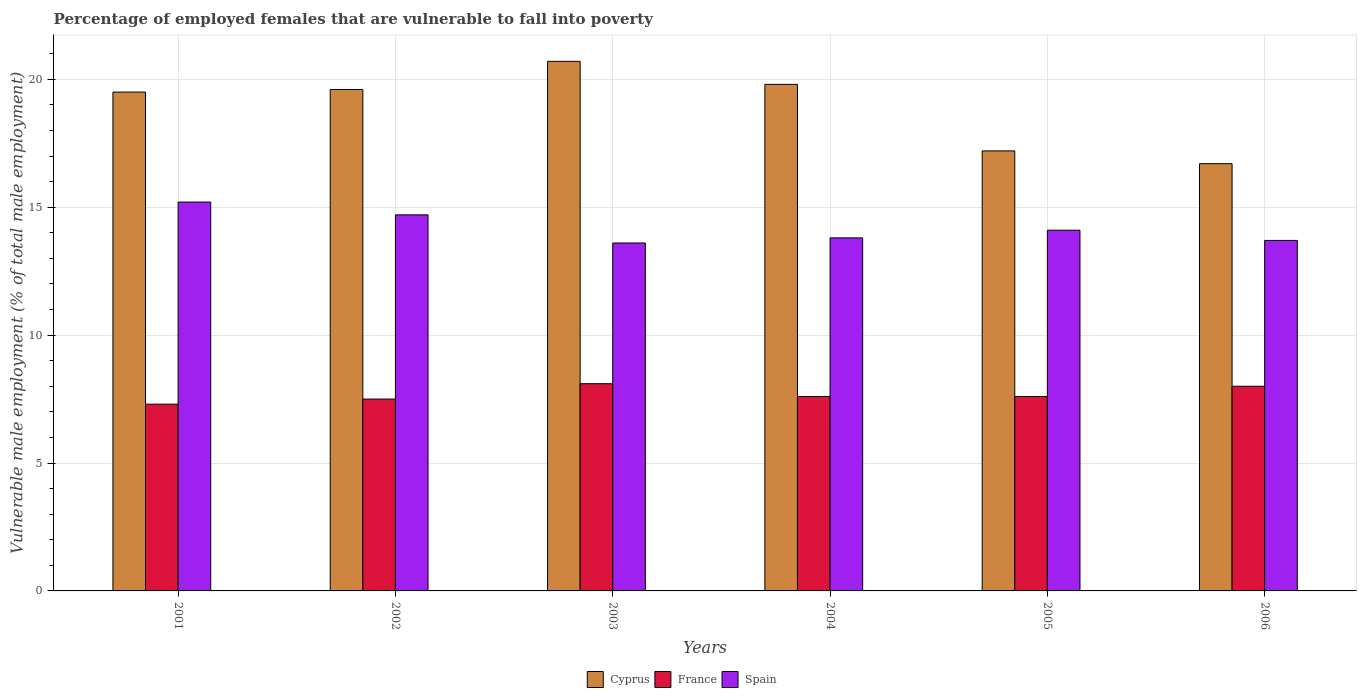Are the number of bars on each tick of the X-axis equal?
Provide a short and direct response. Yes. How many bars are there on the 4th tick from the left?
Your response must be concise. 3. In how many cases, is the number of bars for a given year not equal to the number of legend labels?
Your answer should be compact. 0. What is the percentage of employed females who are vulnerable to fall into poverty in France in 2005?
Offer a terse response. 7.6. Across all years, what is the maximum percentage of employed females who are vulnerable to fall into poverty in France?
Your answer should be very brief. 8.1. Across all years, what is the minimum percentage of employed females who are vulnerable to fall into poverty in France?
Make the answer very short. 7.3. What is the total percentage of employed females who are vulnerable to fall into poverty in Spain in the graph?
Your answer should be compact. 85.1. What is the difference between the percentage of employed females who are vulnerable to fall into poverty in France in 2001 and that in 2004?
Provide a succinct answer. -0.3. What is the difference between the percentage of employed females who are vulnerable to fall into poverty in France in 2001 and the percentage of employed females who are vulnerable to fall into poverty in Spain in 2004?
Offer a terse response. -6.5. What is the average percentage of employed females who are vulnerable to fall into poverty in Cyprus per year?
Keep it short and to the point. 18.92. In the year 2001, what is the difference between the percentage of employed females who are vulnerable to fall into poverty in France and percentage of employed females who are vulnerable to fall into poverty in Spain?
Give a very brief answer. -7.9. What is the ratio of the percentage of employed females who are vulnerable to fall into poverty in France in 2002 to that in 2004?
Provide a succinct answer. 0.99. Is the difference between the percentage of employed females who are vulnerable to fall into poverty in France in 2002 and 2004 greater than the difference between the percentage of employed females who are vulnerable to fall into poverty in Spain in 2002 and 2004?
Make the answer very short. No. What is the difference between the highest and the lowest percentage of employed females who are vulnerable to fall into poverty in Spain?
Make the answer very short. 1.6. In how many years, is the percentage of employed females who are vulnerable to fall into poverty in Cyprus greater than the average percentage of employed females who are vulnerable to fall into poverty in Cyprus taken over all years?
Your answer should be compact. 4. How many bars are there?
Provide a succinct answer. 18. How many years are there in the graph?
Provide a succinct answer. 6. What is the difference between two consecutive major ticks on the Y-axis?
Make the answer very short. 5. Are the values on the major ticks of Y-axis written in scientific E-notation?
Offer a very short reply. No. Does the graph contain grids?
Make the answer very short. Yes. Where does the legend appear in the graph?
Keep it short and to the point. Bottom center. How are the legend labels stacked?
Your answer should be compact. Horizontal. What is the title of the graph?
Provide a short and direct response. Percentage of employed females that are vulnerable to fall into poverty. What is the label or title of the X-axis?
Your answer should be compact. Years. What is the label or title of the Y-axis?
Your answer should be very brief. Vulnerable male employment (% of total male employment). What is the Vulnerable male employment (% of total male employment) in Cyprus in 2001?
Your response must be concise. 19.5. What is the Vulnerable male employment (% of total male employment) of France in 2001?
Your answer should be compact. 7.3. What is the Vulnerable male employment (% of total male employment) in Spain in 2001?
Ensure brevity in your answer.  15.2. What is the Vulnerable male employment (% of total male employment) in Cyprus in 2002?
Offer a terse response. 19.6. What is the Vulnerable male employment (% of total male employment) in Spain in 2002?
Keep it short and to the point. 14.7. What is the Vulnerable male employment (% of total male employment) in Cyprus in 2003?
Your answer should be very brief. 20.7. What is the Vulnerable male employment (% of total male employment) of France in 2003?
Your response must be concise. 8.1. What is the Vulnerable male employment (% of total male employment) in Spain in 2003?
Provide a succinct answer. 13.6. What is the Vulnerable male employment (% of total male employment) of Cyprus in 2004?
Provide a succinct answer. 19.8. What is the Vulnerable male employment (% of total male employment) of France in 2004?
Give a very brief answer. 7.6. What is the Vulnerable male employment (% of total male employment) of Spain in 2004?
Ensure brevity in your answer.  13.8. What is the Vulnerable male employment (% of total male employment) in Cyprus in 2005?
Offer a very short reply. 17.2. What is the Vulnerable male employment (% of total male employment) in France in 2005?
Your answer should be compact. 7.6. What is the Vulnerable male employment (% of total male employment) in Spain in 2005?
Your answer should be compact. 14.1. What is the Vulnerable male employment (% of total male employment) of Cyprus in 2006?
Provide a short and direct response. 16.7. What is the Vulnerable male employment (% of total male employment) in France in 2006?
Keep it short and to the point. 8. What is the Vulnerable male employment (% of total male employment) in Spain in 2006?
Offer a terse response. 13.7. Across all years, what is the maximum Vulnerable male employment (% of total male employment) in Cyprus?
Your answer should be compact. 20.7. Across all years, what is the maximum Vulnerable male employment (% of total male employment) in France?
Ensure brevity in your answer.  8.1. Across all years, what is the maximum Vulnerable male employment (% of total male employment) in Spain?
Provide a short and direct response. 15.2. Across all years, what is the minimum Vulnerable male employment (% of total male employment) in Cyprus?
Keep it short and to the point. 16.7. Across all years, what is the minimum Vulnerable male employment (% of total male employment) in France?
Provide a succinct answer. 7.3. Across all years, what is the minimum Vulnerable male employment (% of total male employment) of Spain?
Make the answer very short. 13.6. What is the total Vulnerable male employment (% of total male employment) of Cyprus in the graph?
Give a very brief answer. 113.5. What is the total Vulnerable male employment (% of total male employment) of France in the graph?
Your response must be concise. 46.1. What is the total Vulnerable male employment (% of total male employment) in Spain in the graph?
Offer a terse response. 85.1. What is the difference between the Vulnerable male employment (% of total male employment) of France in 2001 and that in 2003?
Provide a short and direct response. -0.8. What is the difference between the Vulnerable male employment (% of total male employment) of Spain in 2001 and that in 2003?
Give a very brief answer. 1.6. What is the difference between the Vulnerable male employment (% of total male employment) in France in 2001 and that in 2004?
Ensure brevity in your answer.  -0.3. What is the difference between the Vulnerable male employment (% of total male employment) of Spain in 2001 and that in 2005?
Make the answer very short. 1.1. What is the difference between the Vulnerable male employment (% of total male employment) of France in 2001 and that in 2006?
Your answer should be compact. -0.7. What is the difference between the Vulnerable male employment (% of total male employment) in Cyprus in 2002 and that in 2004?
Give a very brief answer. -0.2. What is the difference between the Vulnerable male employment (% of total male employment) of Cyprus in 2002 and that in 2005?
Your answer should be very brief. 2.4. What is the difference between the Vulnerable male employment (% of total male employment) in France in 2002 and that in 2005?
Provide a short and direct response. -0.1. What is the difference between the Vulnerable male employment (% of total male employment) in Cyprus in 2002 and that in 2006?
Offer a terse response. 2.9. What is the difference between the Vulnerable male employment (% of total male employment) in France in 2002 and that in 2006?
Your answer should be compact. -0.5. What is the difference between the Vulnerable male employment (% of total male employment) in Cyprus in 2003 and that in 2005?
Make the answer very short. 3.5. What is the difference between the Vulnerable male employment (% of total male employment) of France in 2003 and that in 2005?
Give a very brief answer. 0.5. What is the difference between the Vulnerable male employment (% of total male employment) of Spain in 2003 and that in 2005?
Keep it short and to the point. -0.5. What is the difference between the Vulnerable male employment (% of total male employment) of Cyprus in 2003 and that in 2006?
Your answer should be compact. 4. What is the difference between the Vulnerable male employment (% of total male employment) of France in 2003 and that in 2006?
Your answer should be compact. 0.1. What is the difference between the Vulnerable male employment (% of total male employment) of France in 2004 and that in 2005?
Offer a very short reply. 0. What is the difference between the Vulnerable male employment (% of total male employment) in Spain in 2004 and that in 2005?
Ensure brevity in your answer.  -0.3. What is the difference between the Vulnerable male employment (% of total male employment) in Cyprus in 2004 and that in 2006?
Provide a succinct answer. 3.1. What is the difference between the Vulnerable male employment (% of total male employment) of Cyprus in 2005 and that in 2006?
Keep it short and to the point. 0.5. What is the difference between the Vulnerable male employment (% of total male employment) in France in 2005 and that in 2006?
Offer a very short reply. -0.4. What is the difference between the Vulnerable male employment (% of total male employment) in Cyprus in 2001 and the Vulnerable male employment (% of total male employment) in Spain in 2002?
Ensure brevity in your answer.  4.8. What is the difference between the Vulnerable male employment (% of total male employment) in Cyprus in 2001 and the Vulnerable male employment (% of total male employment) in France in 2003?
Your answer should be compact. 11.4. What is the difference between the Vulnerable male employment (% of total male employment) in Cyprus in 2001 and the Vulnerable male employment (% of total male employment) in Spain in 2003?
Provide a succinct answer. 5.9. What is the difference between the Vulnerable male employment (% of total male employment) of France in 2001 and the Vulnerable male employment (% of total male employment) of Spain in 2003?
Provide a succinct answer. -6.3. What is the difference between the Vulnerable male employment (% of total male employment) in Cyprus in 2001 and the Vulnerable male employment (% of total male employment) in France in 2004?
Your response must be concise. 11.9. What is the difference between the Vulnerable male employment (% of total male employment) in Cyprus in 2001 and the Vulnerable male employment (% of total male employment) in Spain in 2004?
Offer a very short reply. 5.7. What is the difference between the Vulnerable male employment (% of total male employment) in France in 2001 and the Vulnerable male employment (% of total male employment) in Spain in 2004?
Provide a short and direct response. -6.5. What is the difference between the Vulnerable male employment (% of total male employment) in Cyprus in 2001 and the Vulnerable male employment (% of total male employment) in France in 2005?
Ensure brevity in your answer.  11.9. What is the difference between the Vulnerable male employment (% of total male employment) of France in 2001 and the Vulnerable male employment (% of total male employment) of Spain in 2005?
Offer a terse response. -6.8. What is the difference between the Vulnerable male employment (% of total male employment) of France in 2001 and the Vulnerable male employment (% of total male employment) of Spain in 2006?
Offer a terse response. -6.4. What is the difference between the Vulnerable male employment (% of total male employment) of Cyprus in 2002 and the Vulnerable male employment (% of total male employment) of Spain in 2003?
Your answer should be compact. 6. What is the difference between the Vulnerable male employment (% of total male employment) of France in 2002 and the Vulnerable male employment (% of total male employment) of Spain in 2003?
Offer a terse response. -6.1. What is the difference between the Vulnerable male employment (% of total male employment) in Cyprus in 2002 and the Vulnerable male employment (% of total male employment) in France in 2004?
Make the answer very short. 12. What is the difference between the Vulnerable male employment (% of total male employment) in Cyprus in 2002 and the Vulnerable male employment (% of total male employment) in Spain in 2004?
Offer a terse response. 5.8. What is the difference between the Vulnerable male employment (% of total male employment) in Cyprus in 2002 and the Vulnerable male employment (% of total male employment) in Spain in 2005?
Offer a very short reply. 5.5. What is the difference between the Vulnerable male employment (% of total male employment) in Cyprus in 2002 and the Vulnerable male employment (% of total male employment) in France in 2006?
Keep it short and to the point. 11.6. What is the difference between the Vulnerable male employment (% of total male employment) of Cyprus in 2003 and the Vulnerable male employment (% of total male employment) of Spain in 2005?
Give a very brief answer. 6.6. What is the difference between the Vulnerable male employment (% of total male employment) of France in 2004 and the Vulnerable male employment (% of total male employment) of Spain in 2005?
Make the answer very short. -6.5. What is the difference between the Vulnerable male employment (% of total male employment) in Cyprus in 2004 and the Vulnerable male employment (% of total male employment) in France in 2006?
Provide a succinct answer. 11.8. What is the difference between the Vulnerable male employment (% of total male employment) in France in 2004 and the Vulnerable male employment (% of total male employment) in Spain in 2006?
Your answer should be compact. -6.1. What is the difference between the Vulnerable male employment (% of total male employment) of Cyprus in 2005 and the Vulnerable male employment (% of total male employment) of France in 2006?
Offer a terse response. 9.2. What is the difference between the Vulnerable male employment (% of total male employment) of France in 2005 and the Vulnerable male employment (% of total male employment) of Spain in 2006?
Keep it short and to the point. -6.1. What is the average Vulnerable male employment (% of total male employment) in Cyprus per year?
Keep it short and to the point. 18.92. What is the average Vulnerable male employment (% of total male employment) of France per year?
Keep it short and to the point. 7.68. What is the average Vulnerable male employment (% of total male employment) of Spain per year?
Offer a terse response. 14.18. In the year 2001, what is the difference between the Vulnerable male employment (% of total male employment) of Cyprus and Vulnerable male employment (% of total male employment) of Spain?
Provide a succinct answer. 4.3. In the year 2001, what is the difference between the Vulnerable male employment (% of total male employment) in France and Vulnerable male employment (% of total male employment) in Spain?
Provide a succinct answer. -7.9. In the year 2003, what is the difference between the Vulnerable male employment (% of total male employment) of Cyprus and Vulnerable male employment (% of total male employment) of Spain?
Make the answer very short. 7.1. In the year 2003, what is the difference between the Vulnerable male employment (% of total male employment) in France and Vulnerable male employment (% of total male employment) in Spain?
Offer a very short reply. -5.5. In the year 2004, what is the difference between the Vulnerable male employment (% of total male employment) of France and Vulnerable male employment (% of total male employment) of Spain?
Keep it short and to the point. -6.2. In the year 2005, what is the difference between the Vulnerable male employment (% of total male employment) of Cyprus and Vulnerable male employment (% of total male employment) of France?
Give a very brief answer. 9.6. In the year 2005, what is the difference between the Vulnerable male employment (% of total male employment) of Cyprus and Vulnerable male employment (% of total male employment) of Spain?
Make the answer very short. 3.1. In the year 2005, what is the difference between the Vulnerable male employment (% of total male employment) in France and Vulnerable male employment (% of total male employment) in Spain?
Ensure brevity in your answer.  -6.5. In the year 2006, what is the difference between the Vulnerable male employment (% of total male employment) in France and Vulnerable male employment (% of total male employment) in Spain?
Keep it short and to the point. -5.7. What is the ratio of the Vulnerable male employment (% of total male employment) of Cyprus in 2001 to that in 2002?
Your response must be concise. 0.99. What is the ratio of the Vulnerable male employment (% of total male employment) in France in 2001 to that in 2002?
Offer a terse response. 0.97. What is the ratio of the Vulnerable male employment (% of total male employment) in Spain in 2001 to that in 2002?
Give a very brief answer. 1.03. What is the ratio of the Vulnerable male employment (% of total male employment) in Cyprus in 2001 to that in 2003?
Provide a short and direct response. 0.94. What is the ratio of the Vulnerable male employment (% of total male employment) in France in 2001 to that in 2003?
Make the answer very short. 0.9. What is the ratio of the Vulnerable male employment (% of total male employment) in Spain in 2001 to that in 2003?
Offer a very short reply. 1.12. What is the ratio of the Vulnerable male employment (% of total male employment) in France in 2001 to that in 2004?
Ensure brevity in your answer.  0.96. What is the ratio of the Vulnerable male employment (% of total male employment) of Spain in 2001 to that in 2004?
Offer a very short reply. 1.1. What is the ratio of the Vulnerable male employment (% of total male employment) of Cyprus in 2001 to that in 2005?
Provide a short and direct response. 1.13. What is the ratio of the Vulnerable male employment (% of total male employment) of France in 2001 to that in 2005?
Offer a terse response. 0.96. What is the ratio of the Vulnerable male employment (% of total male employment) in Spain in 2001 to that in 2005?
Keep it short and to the point. 1.08. What is the ratio of the Vulnerable male employment (% of total male employment) of Cyprus in 2001 to that in 2006?
Offer a very short reply. 1.17. What is the ratio of the Vulnerable male employment (% of total male employment) in France in 2001 to that in 2006?
Keep it short and to the point. 0.91. What is the ratio of the Vulnerable male employment (% of total male employment) in Spain in 2001 to that in 2006?
Offer a terse response. 1.11. What is the ratio of the Vulnerable male employment (% of total male employment) in Cyprus in 2002 to that in 2003?
Offer a terse response. 0.95. What is the ratio of the Vulnerable male employment (% of total male employment) of France in 2002 to that in 2003?
Your answer should be very brief. 0.93. What is the ratio of the Vulnerable male employment (% of total male employment) of Spain in 2002 to that in 2003?
Offer a very short reply. 1.08. What is the ratio of the Vulnerable male employment (% of total male employment) of Cyprus in 2002 to that in 2004?
Your response must be concise. 0.99. What is the ratio of the Vulnerable male employment (% of total male employment) in France in 2002 to that in 2004?
Offer a terse response. 0.99. What is the ratio of the Vulnerable male employment (% of total male employment) of Spain in 2002 to that in 2004?
Your answer should be compact. 1.07. What is the ratio of the Vulnerable male employment (% of total male employment) in Cyprus in 2002 to that in 2005?
Provide a succinct answer. 1.14. What is the ratio of the Vulnerable male employment (% of total male employment) in France in 2002 to that in 2005?
Make the answer very short. 0.99. What is the ratio of the Vulnerable male employment (% of total male employment) in Spain in 2002 to that in 2005?
Provide a succinct answer. 1.04. What is the ratio of the Vulnerable male employment (% of total male employment) in Cyprus in 2002 to that in 2006?
Provide a short and direct response. 1.17. What is the ratio of the Vulnerable male employment (% of total male employment) of Spain in 2002 to that in 2006?
Offer a terse response. 1.07. What is the ratio of the Vulnerable male employment (% of total male employment) of Cyprus in 2003 to that in 2004?
Ensure brevity in your answer.  1.05. What is the ratio of the Vulnerable male employment (% of total male employment) in France in 2003 to that in 2004?
Provide a succinct answer. 1.07. What is the ratio of the Vulnerable male employment (% of total male employment) in Spain in 2003 to that in 2004?
Your answer should be compact. 0.99. What is the ratio of the Vulnerable male employment (% of total male employment) in Cyprus in 2003 to that in 2005?
Your answer should be very brief. 1.2. What is the ratio of the Vulnerable male employment (% of total male employment) in France in 2003 to that in 2005?
Make the answer very short. 1.07. What is the ratio of the Vulnerable male employment (% of total male employment) of Spain in 2003 to that in 2005?
Your answer should be very brief. 0.96. What is the ratio of the Vulnerable male employment (% of total male employment) in Cyprus in 2003 to that in 2006?
Your response must be concise. 1.24. What is the ratio of the Vulnerable male employment (% of total male employment) of France in 2003 to that in 2006?
Your response must be concise. 1.01. What is the ratio of the Vulnerable male employment (% of total male employment) of Spain in 2003 to that in 2006?
Your response must be concise. 0.99. What is the ratio of the Vulnerable male employment (% of total male employment) in Cyprus in 2004 to that in 2005?
Make the answer very short. 1.15. What is the ratio of the Vulnerable male employment (% of total male employment) of Spain in 2004 to that in 2005?
Your answer should be very brief. 0.98. What is the ratio of the Vulnerable male employment (% of total male employment) of Cyprus in 2004 to that in 2006?
Give a very brief answer. 1.19. What is the ratio of the Vulnerable male employment (% of total male employment) in Spain in 2004 to that in 2006?
Offer a very short reply. 1.01. What is the ratio of the Vulnerable male employment (% of total male employment) in Cyprus in 2005 to that in 2006?
Your answer should be compact. 1.03. What is the ratio of the Vulnerable male employment (% of total male employment) of France in 2005 to that in 2006?
Your response must be concise. 0.95. What is the ratio of the Vulnerable male employment (% of total male employment) in Spain in 2005 to that in 2006?
Your response must be concise. 1.03. What is the difference between the highest and the second highest Vulnerable male employment (% of total male employment) of France?
Offer a terse response. 0.1. What is the difference between the highest and the second highest Vulnerable male employment (% of total male employment) of Spain?
Provide a succinct answer. 0.5. What is the difference between the highest and the lowest Vulnerable male employment (% of total male employment) in Cyprus?
Your answer should be very brief. 4. What is the difference between the highest and the lowest Vulnerable male employment (% of total male employment) of France?
Provide a short and direct response. 0.8. What is the difference between the highest and the lowest Vulnerable male employment (% of total male employment) of Spain?
Your answer should be compact. 1.6. 